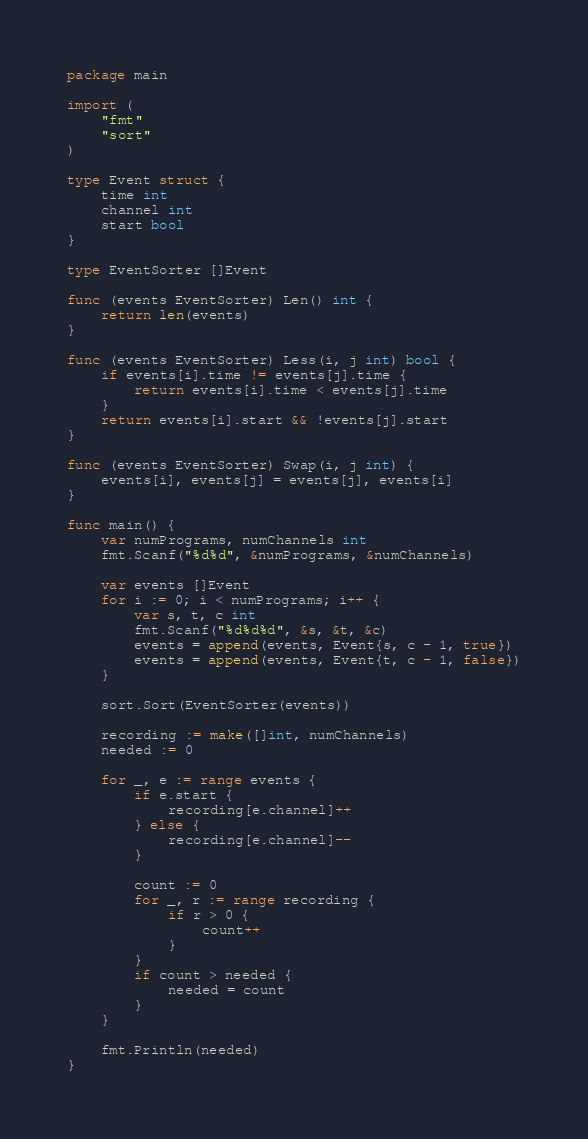<code> <loc_0><loc_0><loc_500><loc_500><_Go_>package main

import (
	"fmt"
	"sort"
)

type Event struct {
	time int
	channel int
	start bool
}

type EventSorter []Event

func (events EventSorter) Len() int {
	return len(events)
}

func (events EventSorter) Less(i, j int) bool {
	if events[i].time != events[j].time {
		return events[i].time < events[j].time
	}
	return events[i].start && !events[j].start
}

func (events EventSorter) Swap(i, j int) {
	events[i], events[j] = events[j], events[i]
}

func main() {
	var numPrograms, numChannels int
	fmt.Scanf("%d%d", &numPrograms, &numChannels)

	var events []Event
	for i := 0; i < numPrograms; i++ {
		var s, t, c int
		fmt.Scanf("%d%d%d", &s, &t, &c)
		events = append(events, Event{s, c - 1, true})
		events = append(events, Event{t, c - 1, false})
	}

	sort.Sort(EventSorter(events))

	recording := make([]int, numChannels)
	needed := 0

	for _, e := range events {
		if e.start {
			recording[e.channel]++
		} else {
			recording[e.channel]--
		}

		count := 0
		for _, r := range recording {
			if r > 0 {
				count++
			}
		}
		if count > needed {
			needed = count
		}
	}

	fmt.Println(needed)
}
</code> 